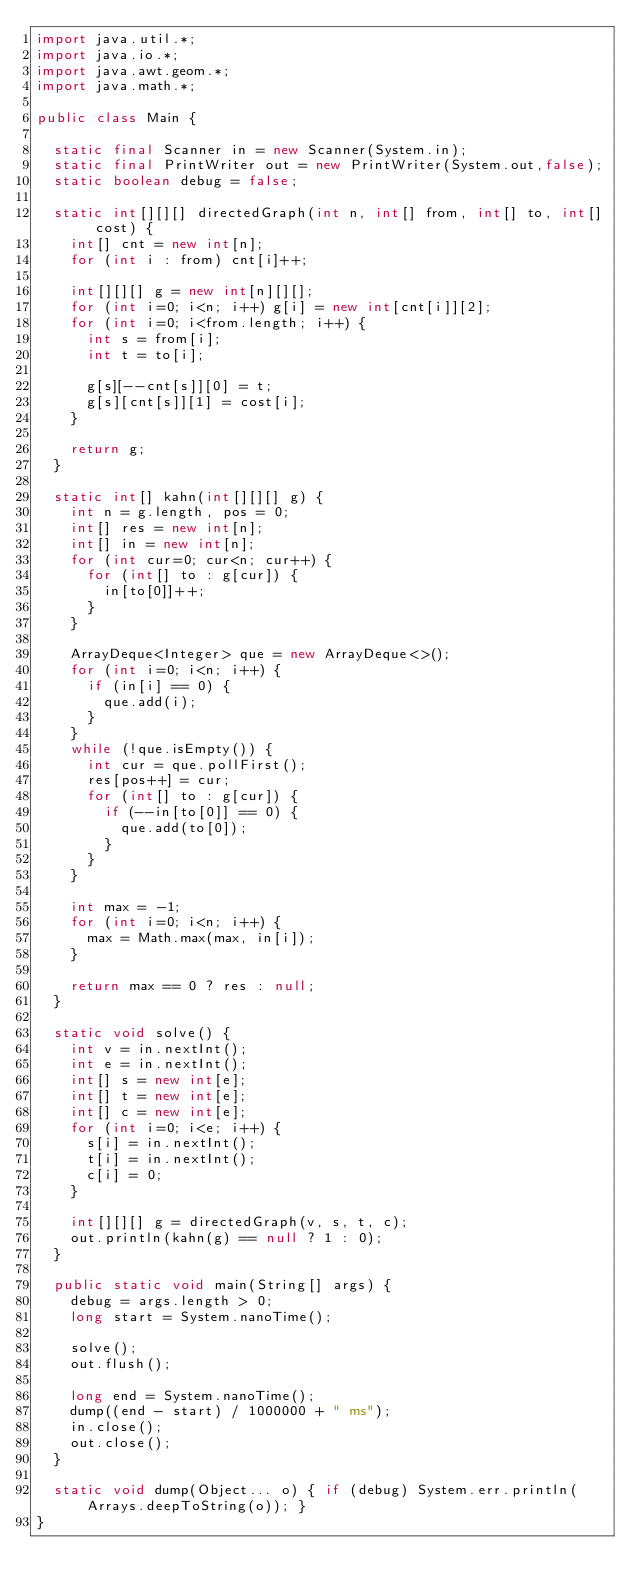<code> <loc_0><loc_0><loc_500><loc_500><_Java_>import java.util.*;
import java.io.*;
import java.awt.geom.*;
import java.math.*;

public class Main {

	static final Scanner in = new Scanner(System.in);
	static final PrintWriter out = new PrintWriter(System.out,false);
	static boolean debug = false;

	static int[][][] directedGraph(int n, int[] from, int[] to, int[] cost) {
		int[] cnt = new int[n];
		for (int i : from) cnt[i]++;

		int[][][] g = new int[n][][];
		for (int i=0; i<n; i++) g[i] = new int[cnt[i]][2];
		for (int i=0; i<from.length; i++) {
			int s = from[i];
			int t = to[i];

			g[s][--cnt[s]][0] = t;
			g[s][cnt[s]][1] = cost[i];
		}

		return g;
	}

	static int[] kahn(int[][][] g) {
		int n = g.length, pos = 0;
		int[] res = new int[n];
		int[] in = new int[n];
		for (int cur=0; cur<n; cur++) {
			for (int[] to : g[cur]) {
				in[to[0]]++;
			}
		}

		ArrayDeque<Integer> que = new ArrayDeque<>();
		for (int i=0; i<n; i++) {
			if (in[i] == 0) {
				que.add(i);
			}
		}
		while (!que.isEmpty()) {
			int cur = que.pollFirst();
			res[pos++] = cur;
			for (int[] to : g[cur]) {
				if (--in[to[0]] == 0) {
					que.add(to[0]);
				}
			}
		}

		int max = -1;
		for (int i=0; i<n; i++) {
			max = Math.max(max, in[i]);
		}

		return max == 0 ? res : null;
	}

	static void solve() {
		int v = in.nextInt();
		int e = in.nextInt();
		int[] s = new int[e];
		int[] t = new int[e];
		int[] c = new int[e];
		for (int i=0; i<e; i++) {
			s[i] = in.nextInt();
			t[i] = in.nextInt();
			c[i] = 0;
		}

		int[][][] g = directedGraph(v, s, t, c);
		out.println(kahn(g) == null ? 1 : 0);
	}

	public static void main(String[] args) {
		debug = args.length > 0;
		long start = System.nanoTime();

		solve();
		out.flush();

		long end = System.nanoTime();
		dump((end - start) / 1000000 + " ms");
		in.close();
		out.close();
	}

	static void dump(Object... o) { if (debug) System.err.println(Arrays.deepToString(o)); }
}</code> 